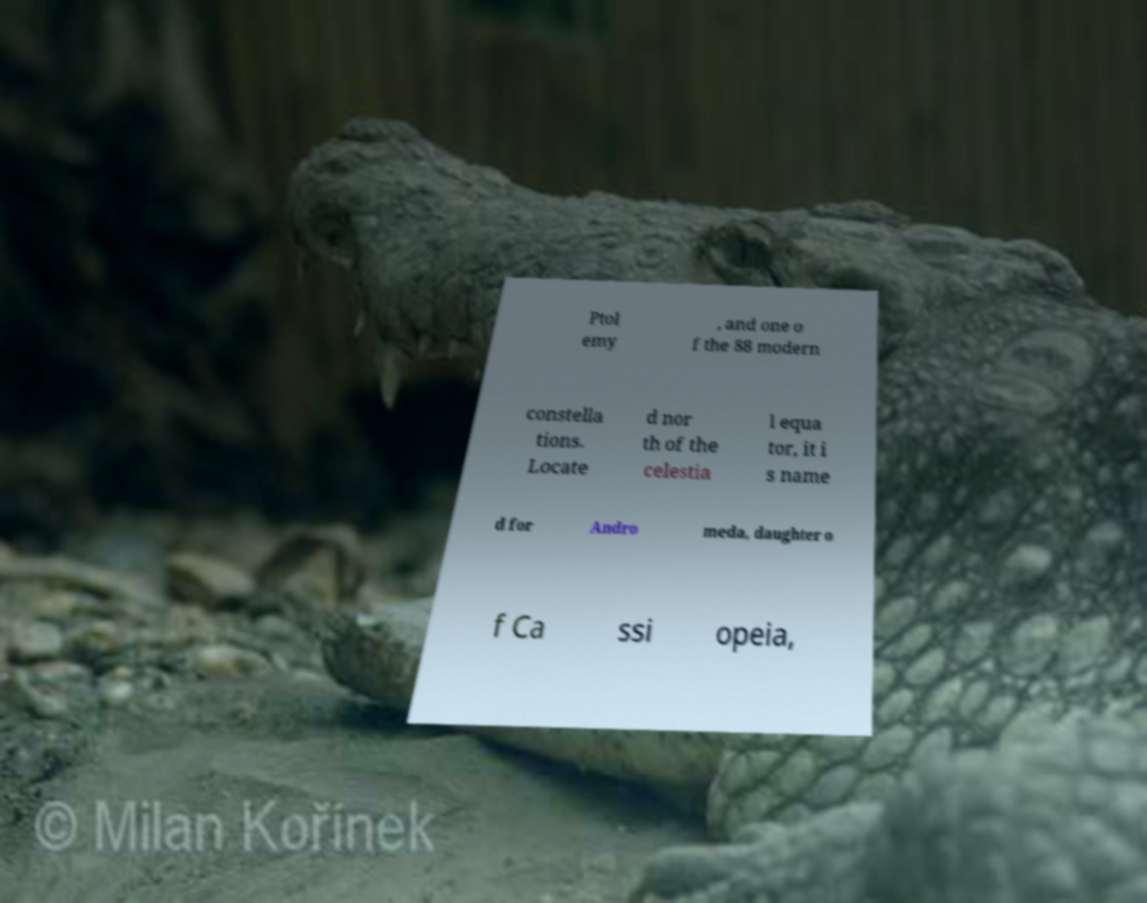There's text embedded in this image that I need extracted. Can you transcribe it verbatim? Ptol emy , and one o f the 88 modern constella tions. Locate d nor th of the celestia l equa tor, it i s name d for Andro meda, daughter o f Ca ssi opeia, 